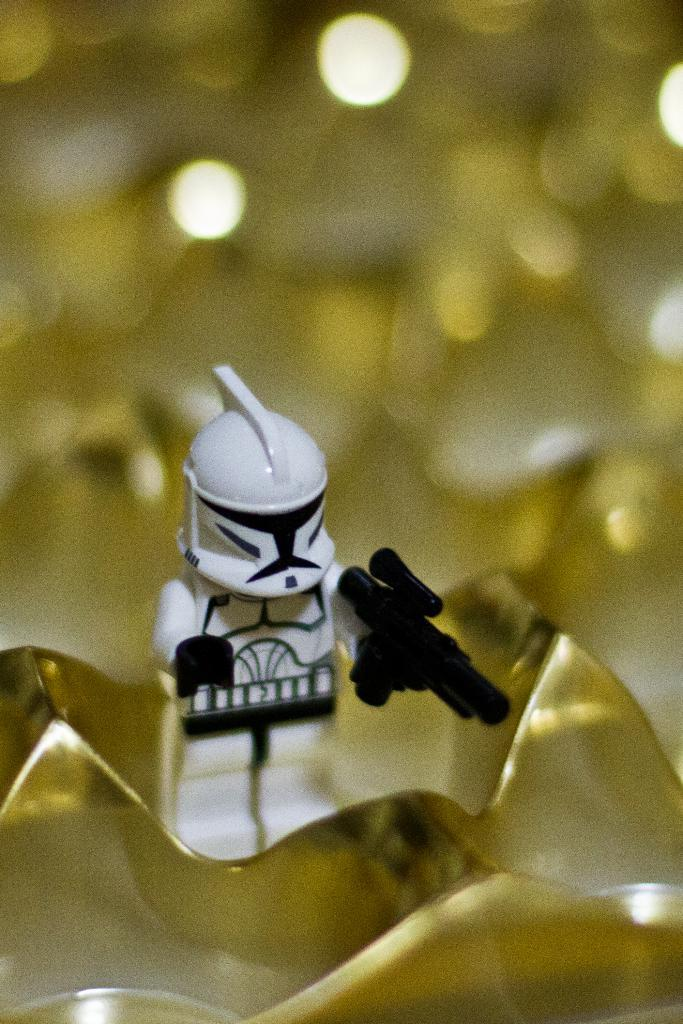Who is the main subject in the image? There is a person (presumably the speaker) in the image. Where is the person located in the image? The person is on a platform. What can be observed about the background of the image? The background of the image is blurry. What type of government is depicted in the image? There is no depiction of a government in the image; it features a person on a platform with a blurry background. 